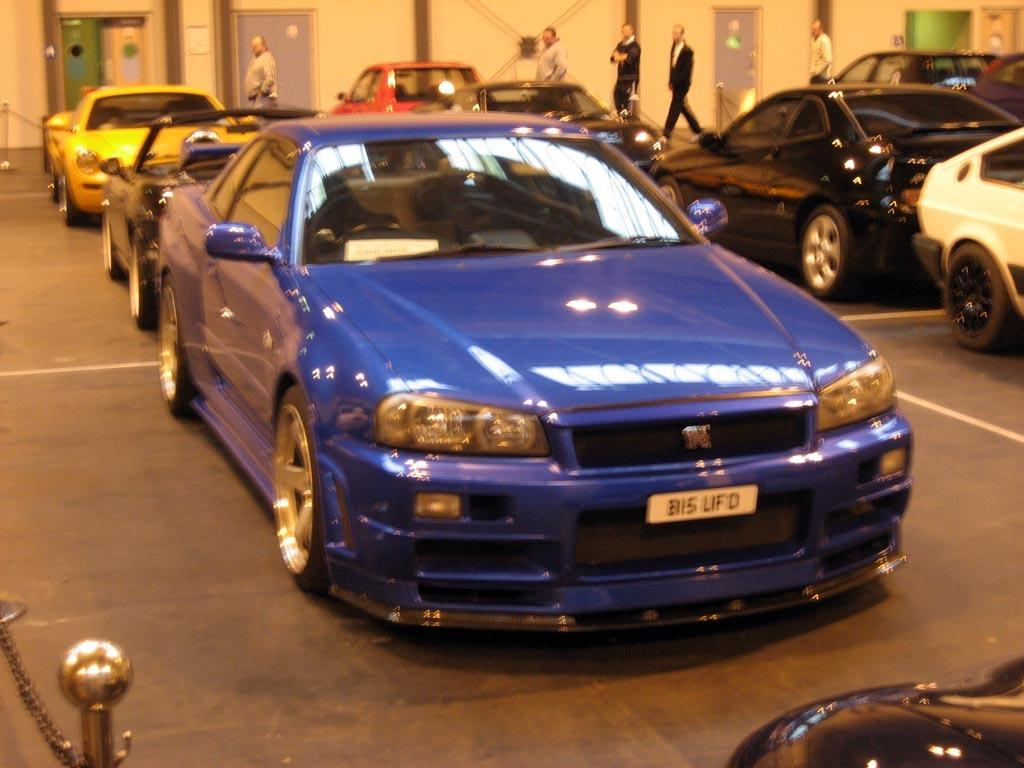What is the main subject of the image? The main subject of the image is the many cars on the road. Are there any other people or objects visible in the image? Yes, there are people walking in the back of the image. Where are the people walking in relation to the building? The people are walking in front of a building. What type of beef is being served at the houses in the image? There are no houses or beef present in the image; it features cars on the road and people walking in front of a building. 